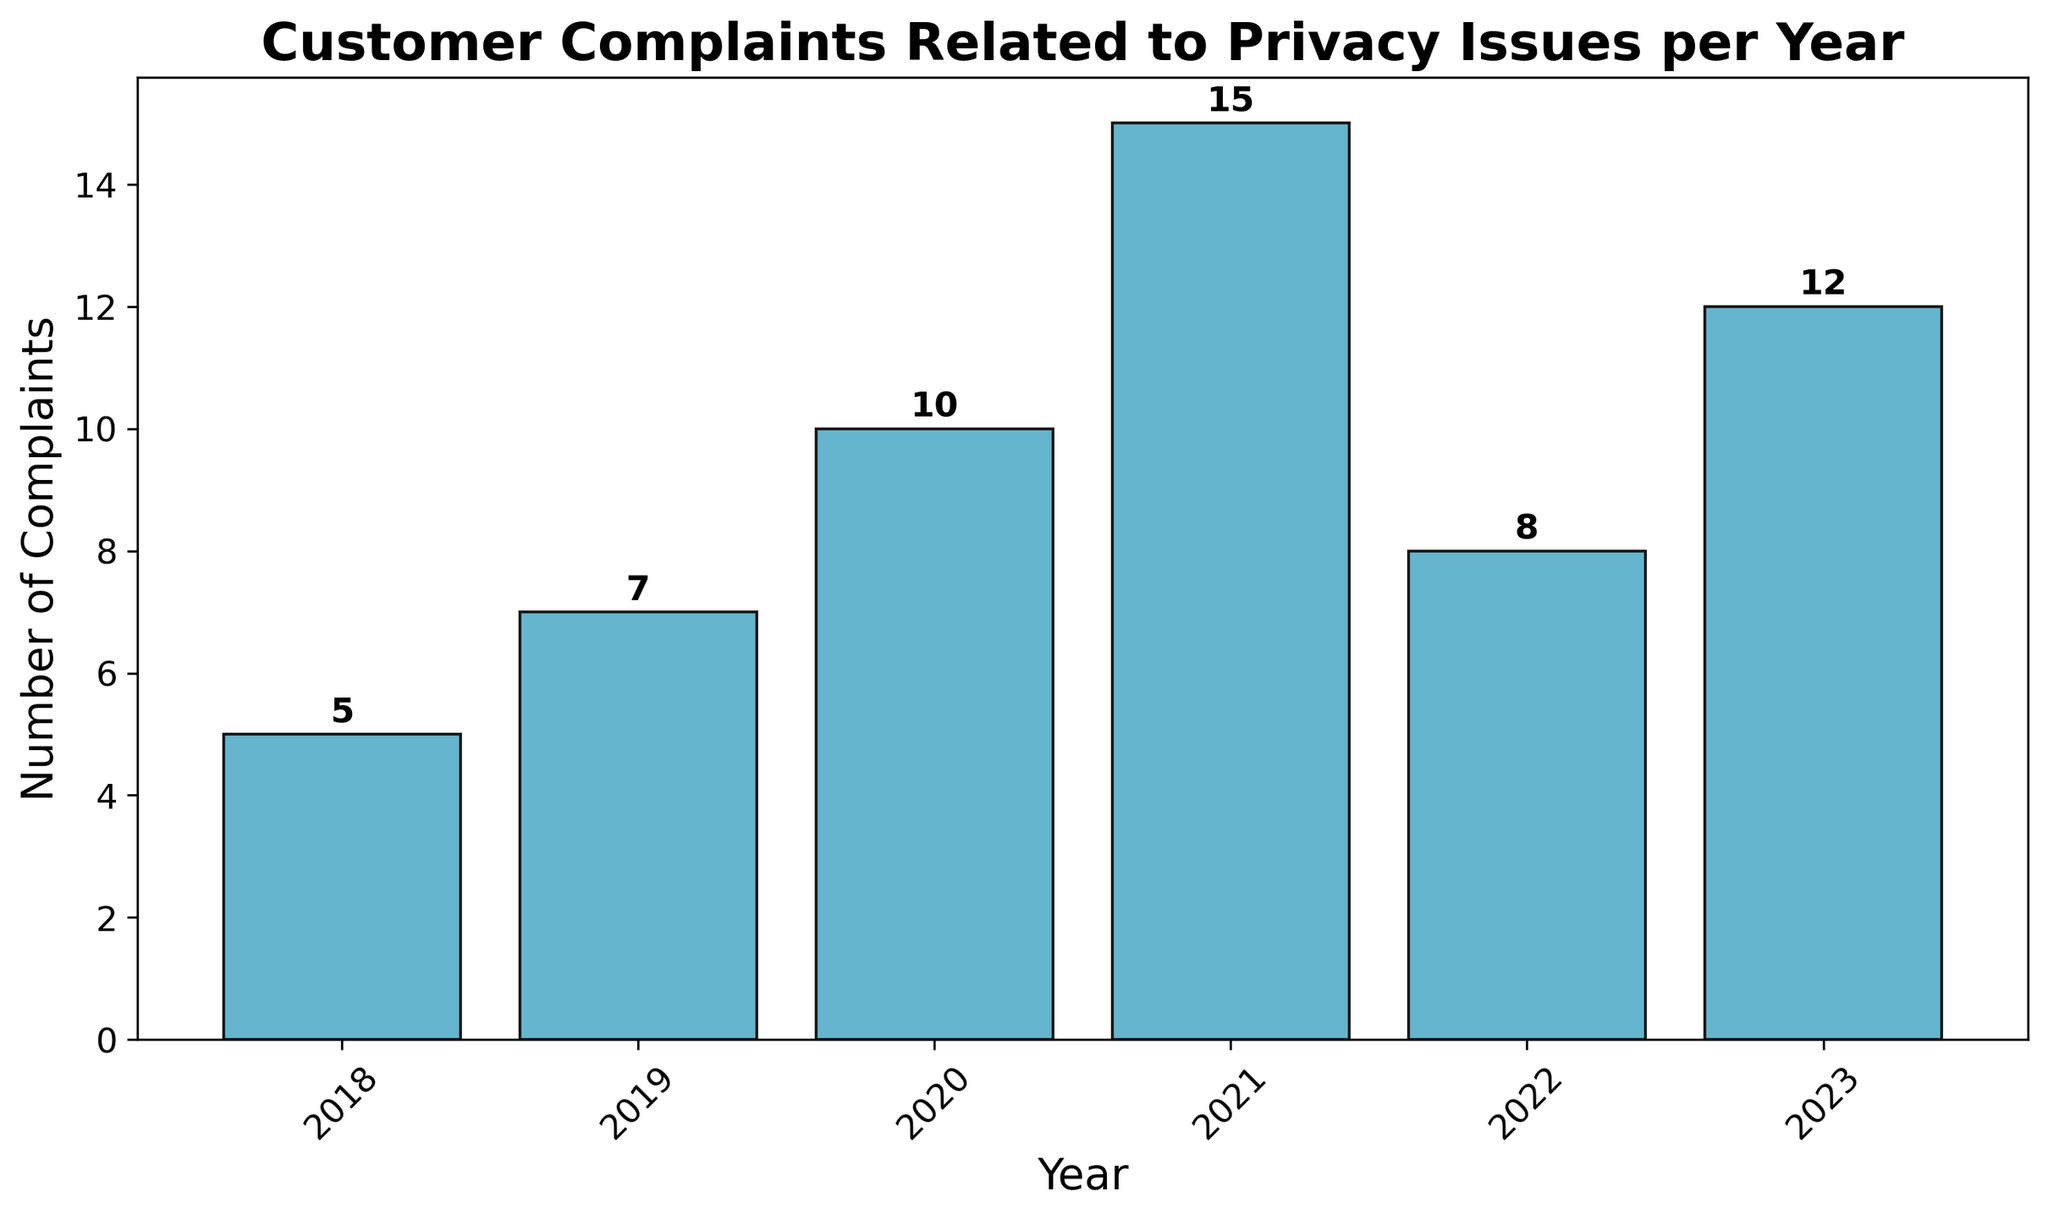How many more complaints were there in 2023 compared to 2018? The bar for 2023 shows 12 complaints, and the bar for 2018 shows 5 complaints. The difference is 12 - 5 = 7.
Answer: 7 What is the average number of complaints over the six years presented? To calculate the average, sum the number of complaints for all years and divide by the number of years: (5 + 7 + 10 + 15 + 8 + 12) / 6 = 57 / 6 = 9.5.
Answer: 9.5 In which year did the number of complaints decrease the most from the previous year? Looking at the bars, the number decreased the most between 2021 (15 complaints) and 2022 (8 complaints). The decrease is 15 - 8 = 7 complaints.
Answer: 2022 Which year had the highest number of customer complaints related to privacy issues? The tallest bar represents 2021 with 15 complaints.
Answer: 2021 What is the total number of complaints reported from 2018 to 2020? Sum the complaints for the years 2018, 2019, and 2020: 5 + 7 + 10 = 22.
Answer: 22 How many years had fewer than 10 complaints? By counting the bars representing fewer than 10 complaints, these years are 2018 (5 complaints), 2019 (7 complaints), and 2022 (8 complaints). This makes three years.
Answer: 3 From 2018 to 2021, how did the number of complaints trend? Observing the bars for these years: 2018 (5), 2019 (7), 2020 (10), and 2021 (15), the number of complaints increased every year.
Answer: Increased How much did the number of complaints change from 2022 to 2023? The number of complaints in 2022 was 8, and in 2023, it was 12. The change is 12 - 8 = 4.
Answer: 4 Which two consecutive years had the largest increase in complaints? The largest increase occurred between 2020 (10 complaints) and 2021 (15 complaints), an increase of 5.
Answer: 2020 to 2021 Between which years did the number of complaints decrease? The number of complaints decreased between 2021 (15 complaints) and 2022 (8 complaints).
Answer: 2021-2022 